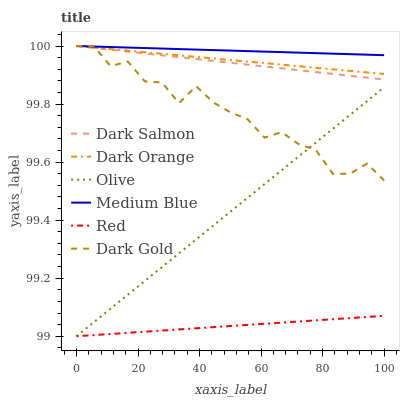Does Red have the minimum area under the curve?
Answer yes or no. Yes. Does Medium Blue have the maximum area under the curve?
Answer yes or no. Yes. Does Dark Gold have the minimum area under the curve?
Answer yes or no. No. Does Dark Gold have the maximum area under the curve?
Answer yes or no. No. Is Red the smoothest?
Answer yes or no. Yes. Is Dark Gold the roughest?
Answer yes or no. Yes. Is Medium Blue the smoothest?
Answer yes or no. No. Is Medium Blue the roughest?
Answer yes or no. No. Does Olive have the lowest value?
Answer yes or no. Yes. Does Dark Gold have the lowest value?
Answer yes or no. No. Does Dark Salmon have the highest value?
Answer yes or no. Yes. Does Olive have the highest value?
Answer yes or no. No. Is Olive less than Dark Orange?
Answer yes or no. Yes. Is Dark Salmon greater than Olive?
Answer yes or no. Yes. Does Medium Blue intersect Dark Orange?
Answer yes or no. Yes. Is Medium Blue less than Dark Orange?
Answer yes or no. No. Is Medium Blue greater than Dark Orange?
Answer yes or no. No. Does Olive intersect Dark Orange?
Answer yes or no. No. 